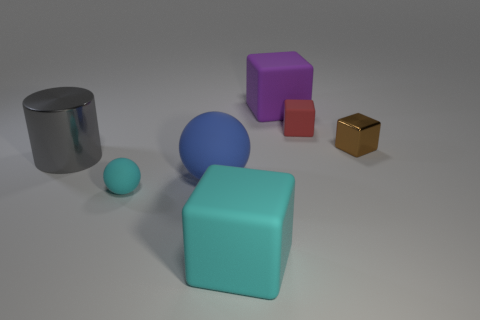Subtract all brown cubes. How many cubes are left? 3 Subtract all yellow blocks. Subtract all purple balls. How many blocks are left? 4 Add 3 blue blocks. How many objects exist? 10 Subtract all spheres. How many objects are left? 5 Add 2 red rubber objects. How many red rubber objects are left? 3 Add 6 small brown blocks. How many small brown blocks exist? 7 Subtract 0 purple cylinders. How many objects are left? 7 Subtract all tiny cyan rubber things. Subtract all gray cylinders. How many objects are left? 5 